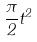<formula> <loc_0><loc_0><loc_500><loc_500>\frac { \pi } { 2 } t ^ { 2 }</formula> 